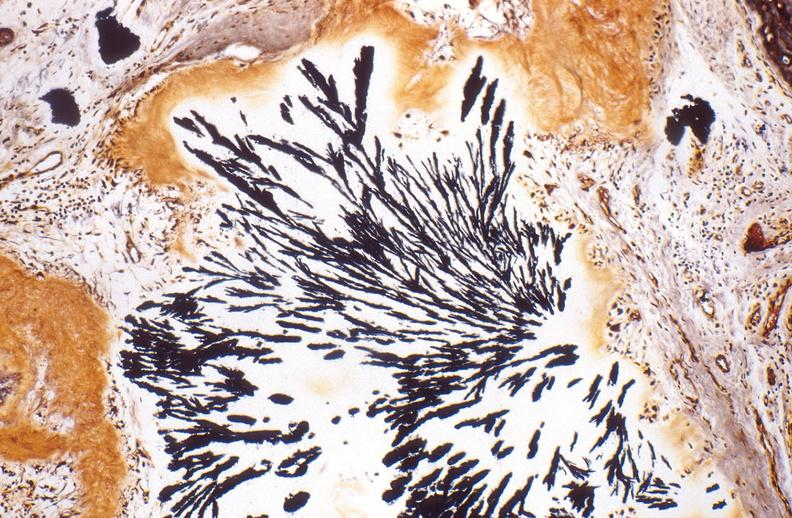s joints present?
Answer the question using a single word or phrase. Yes 